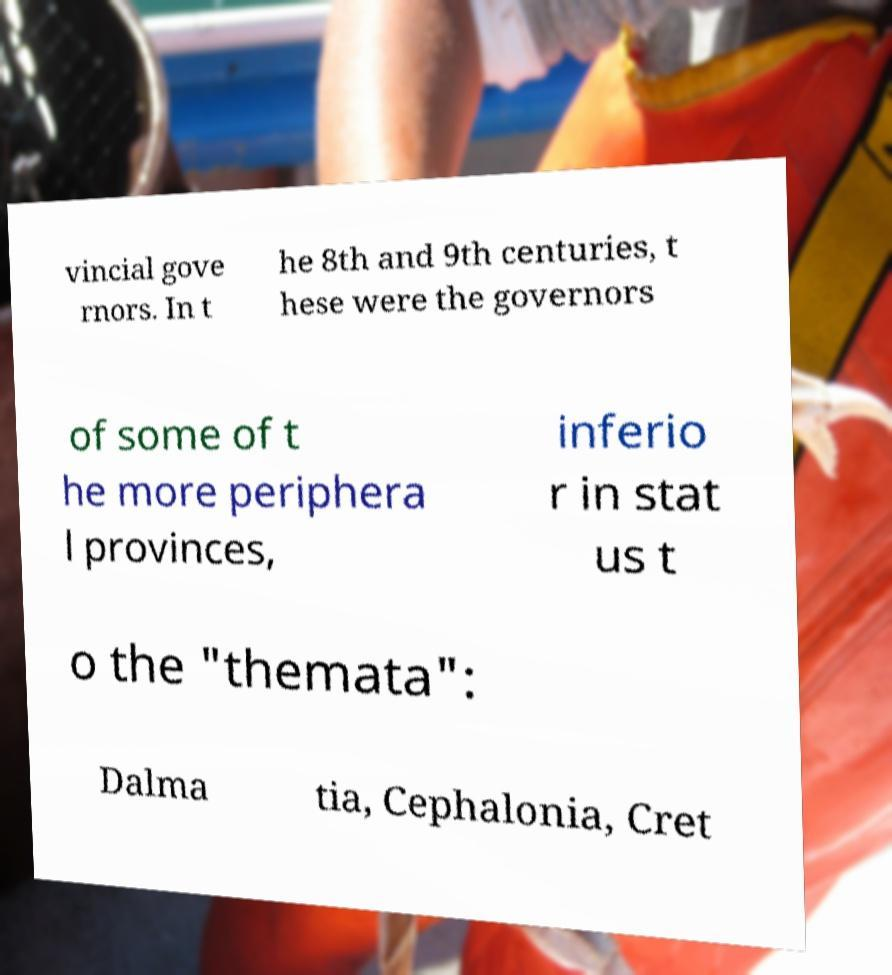Please read and relay the text visible in this image. What does it say? vincial gove rnors. In t he 8th and 9th centuries, t hese were the governors of some of t he more periphera l provinces, inferio r in stat us t o the "themata": Dalma tia, Cephalonia, Cret 